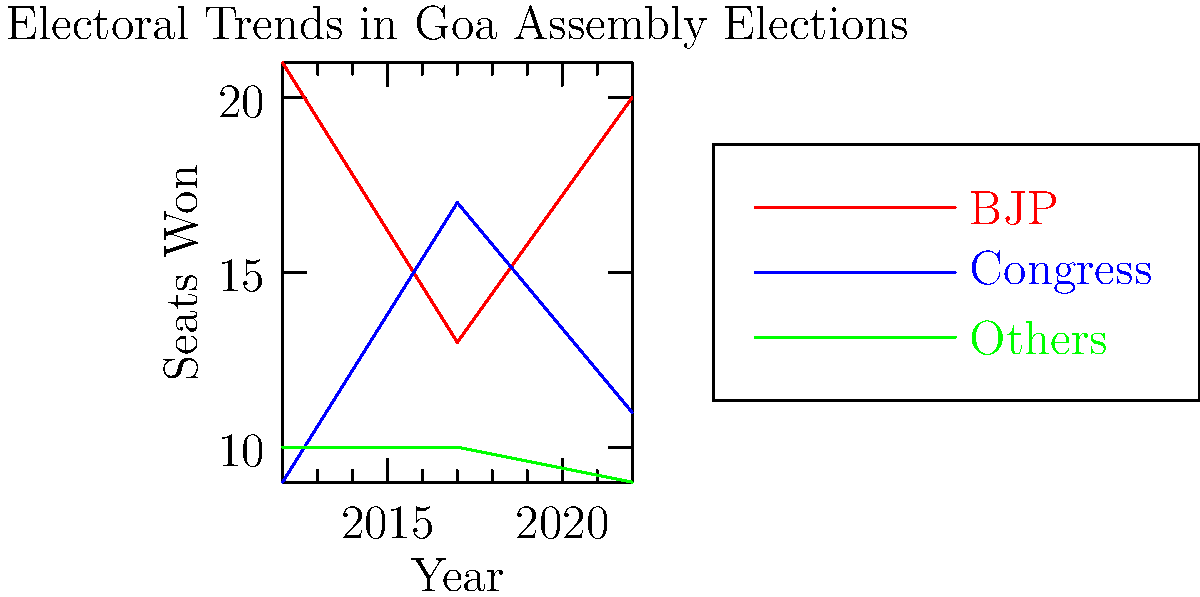Based on the line graph showing the electoral trends in Goa Assembly Elections, what conclusion can be drawn about the performance of the Indian National Congress (INC) in comparison to the Bharatiya Janata Party (BJP) over the three election cycles? How might this trend influence the party's strategy for future elections? To analyze the performance of the Indian National Congress (INC) in comparison to the Bharatiya Janata Party (BJP), we need to examine the trends for both parties over the three election cycles shown in the graph:

1. 2012 Election:
   - BJP: 21 seats
   - INC: 9 seats
   BJP had a clear advantage.

2. 2017 Election:
   - BJP: 13 seats
   - INC: 17 seats
   INC showed significant improvement, overtaking BJP.

3. 2022 Election:
   - BJP: 20 seats
   - INC: 11 seats
   BJP regained its lead, while INC lost ground.

Observations:
1. INC's performance has been inconsistent, with a peak in 2017 but declining in 2022.
2. BJP has maintained a stronger overall position, despite the dip in 2017.
3. The gap between BJP and INC widened again in 2022, similar to 2012.

This trend suggests that:
1. INC's 2017 success was not sustained, indicating potential issues in maintaining voter support.
2. BJP has shown resilience and ability to recover from setbacks.
3. The volatile nature of Goan politics, with significant swings between elections.

For future strategy, INC might consider:
1. Analyzing factors that led to their 2017 success and 2022 decline.
2. Strengthening their local leadership and grassroots presence.
3. Focusing on key issues that resonate with Goan voters.
4. Building a more consistent and sustainable electoral strategy to compete with BJP's strong position.
Answer: INC showed improvement in 2017 but lost ground in 2022, while BJP maintained overall dominance. INC needs to analyze its 2017 success and 2022 decline to build a more consistent and competitive strategy for future elections. 